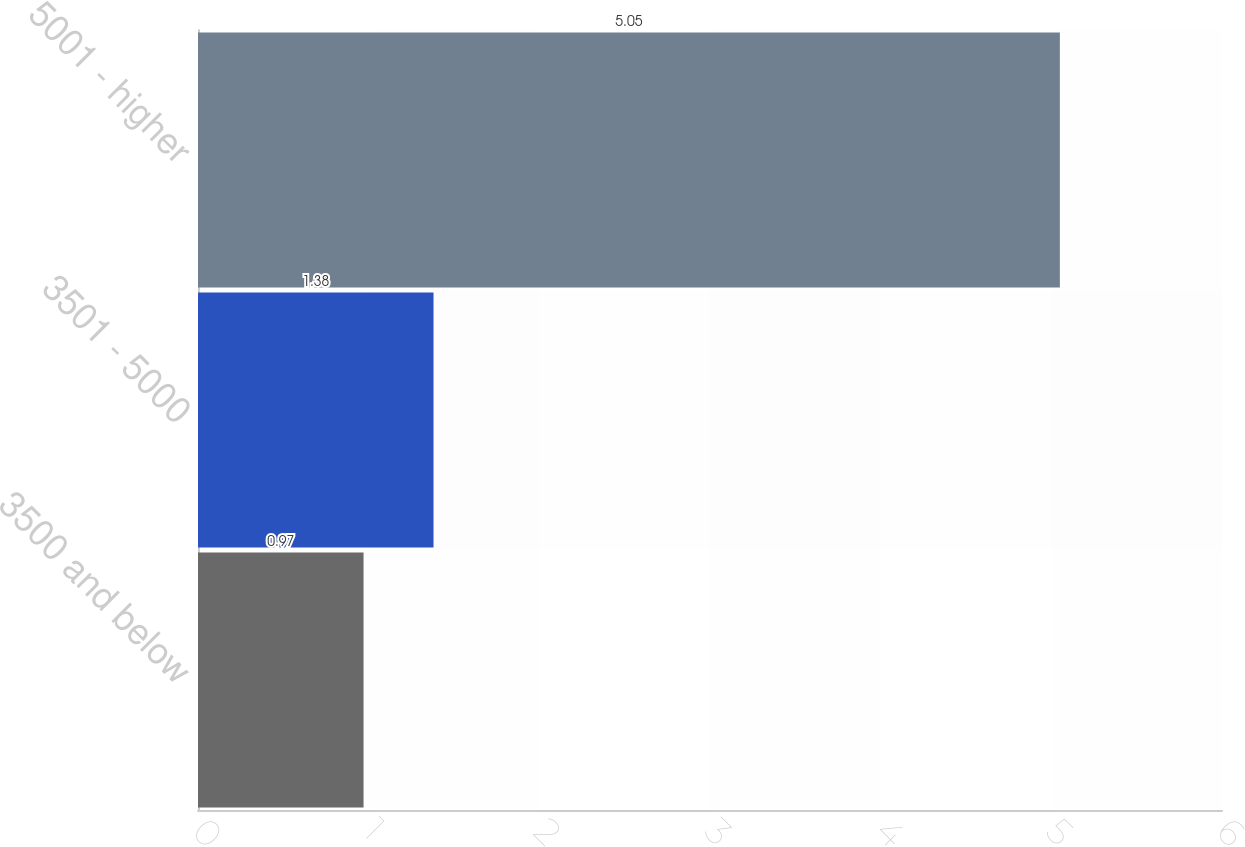<chart> <loc_0><loc_0><loc_500><loc_500><bar_chart><fcel>3500 and below<fcel>3501 - 5000<fcel>5001 - higher<nl><fcel>0.97<fcel>1.38<fcel>5.05<nl></chart> 